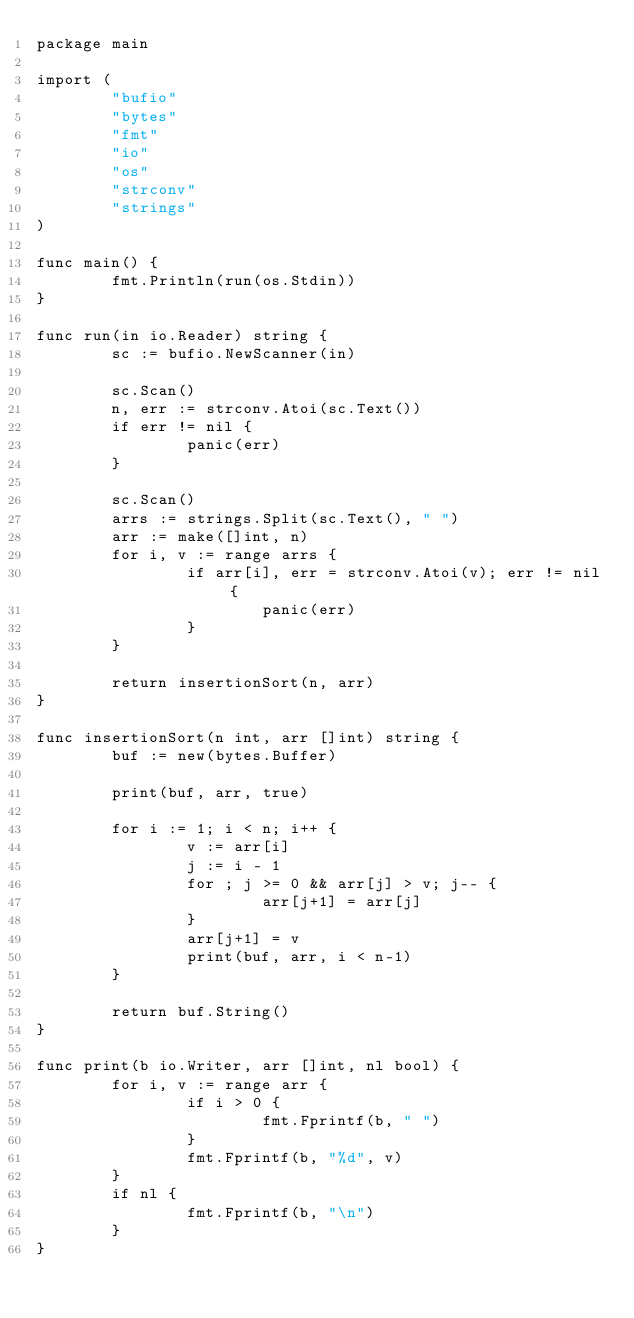<code> <loc_0><loc_0><loc_500><loc_500><_Go_>package main

import (
        "bufio"
        "bytes"
        "fmt"
        "io"
        "os"
        "strconv"
        "strings"
)

func main() {
        fmt.Println(run(os.Stdin))
}

func run(in io.Reader) string {
        sc := bufio.NewScanner(in)

        sc.Scan()
        n, err := strconv.Atoi(sc.Text())
        if err != nil {
                panic(err)
        }

        sc.Scan()
        arrs := strings.Split(sc.Text(), " ")
        arr := make([]int, n)
        for i, v := range arrs {
                if arr[i], err = strconv.Atoi(v); err != nil {
                        panic(err)
                }
        }

        return insertionSort(n, arr)
}

func insertionSort(n int, arr []int) string {
        buf := new(bytes.Buffer)

        print(buf, arr, true)

        for i := 1; i < n; i++ {
                v := arr[i]
                j := i - 1
                for ; j >= 0 && arr[j] > v; j-- {
                        arr[j+1] = arr[j]
                }
                arr[j+1] = v
                print(buf, arr, i < n-1)
        }

        return buf.String()
}

func print(b io.Writer, arr []int, nl bool) {
        for i, v := range arr {
                if i > 0 {
                        fmt.Fprintf(b, " ")
                }
                fmt.Fprintf(b, "%d", v)
        }
        if nl {
                fmt.Fprintf(b, "\n")
        }
}

</code> 